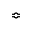Convert formula to latex. <formula><loc_0><loc_0><loc_500><loc_500>\ B u m p e q</formula> 